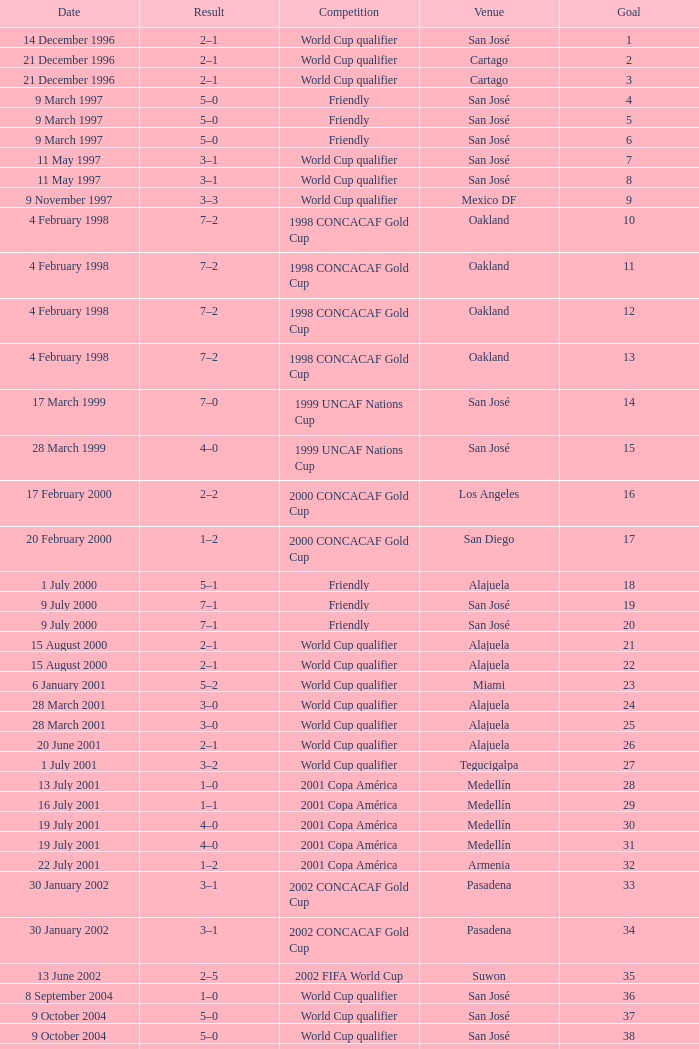What is the result in oakland? 7–2, 7–2, 7–2, 7–2. 